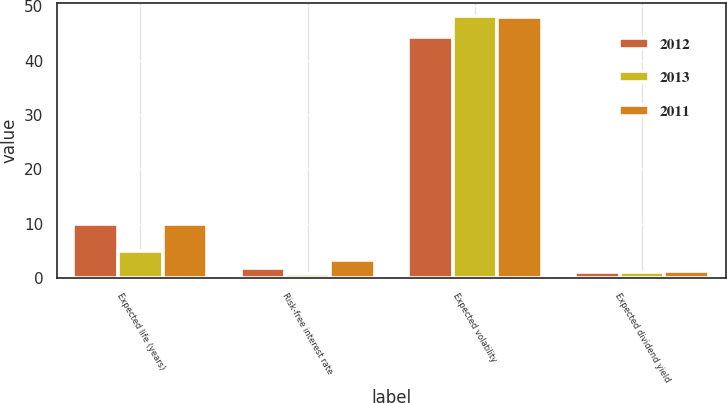Convert chart. <chart><loc_0><loc_0><loc_500><loc_500><stacked_bar_chart><ecel><fcel>Expected life (years)<fcel>Risk-free interest rate<fcel>Expected volatility<fcel>Expected dividend yield<nl><fcel>2012<fcel>9.9<fcel>1.9<fcel>44.3<fcel>1.2<nl><fcel>2013<fcel>5<fcel>0.7<fcel>48.2<fcel>1.2<nl><fcel>2011<fcel>9.9<fcel>3.3<fcel>48<fcel>1.3<nl></chart> 